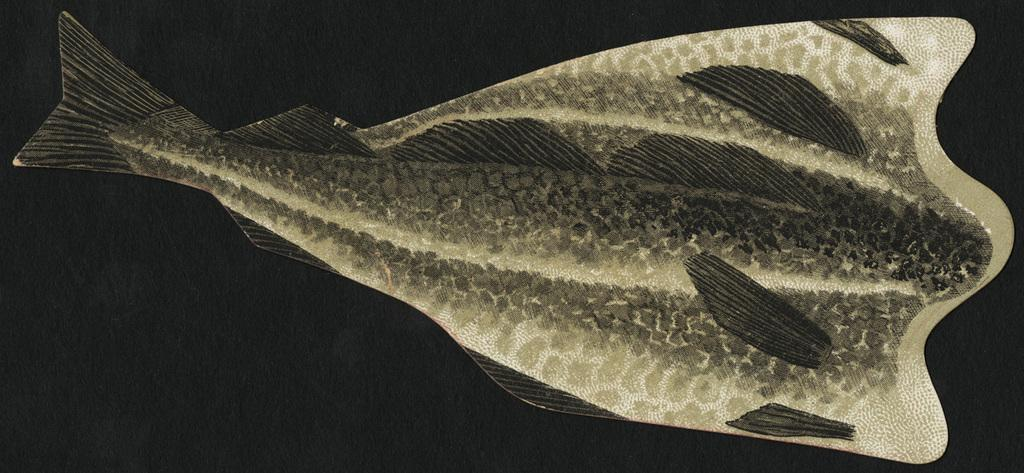What type of animal is present in the image? There is a fish in the image. How many trees are visible in the image? There are no trees present in the image; it only features a fish. What color is the crayon used to draw the fish in the image? There is no crayon or drawing present in the image; it is a photograph or representation of an actual fish. 